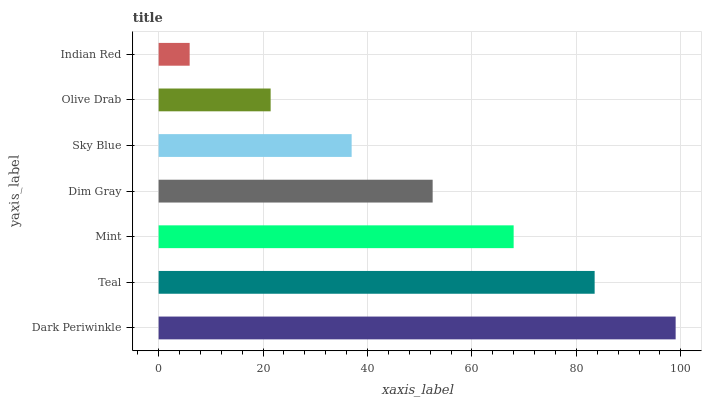Is Indian Red the minimum?
Answer yes or no. Yes. Is Dark Periwinkle the maximum?
Answer yes or no. Yes. Is Teal the minimum?
Answer yes or no. No. Is Teal the maximum?
Answer yes or no. No. Is Dark Periwinkle greater than Teal?
Answer yes or no. Yes. Is Teal less than Dark Periwinkle?
Answer yes or no. Yes. Is Teal greater than Dark Periwinkle?
Answer yes or no. No. Is Dark Periwinkle less than Teal?
Answer yes or no. No. Is Dim Gray the high median?
Answer yes or no. Yes. Is Dim Gray the low median?
Answer yes or no. Yes. Is Sky Blue the high median?
Answer yes or no. No. Is Dark Periwinkle the low median?
Answer yes or no. No. 